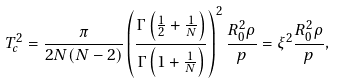Convert formula to latex. <formula><loc_0><loc_0><loc_500><loc_500>T _ { c } ^ { 2 } = \frac { \pi } { 2 N ( N - 2 ) } \left ( \frac { \Gamma \left ( \frac { 1 } { 2 } + \frac { 1 } { N } \right ) } { \Gamma \left ( 1 + \frac { 1 } { N } \right ) } \right ) ^ { 2 } \frac { R _ { 0 } ^ { 2 } \rho } { p } = \xi ^ { 2 } \frac { R _ { 0 } ^ { 2 } \rho } { p } ,</formula> 